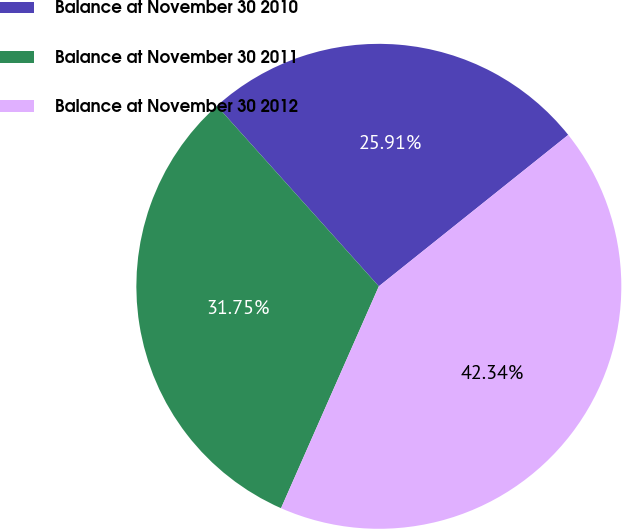<chart> <loc_0><loc_0><loc_500><loc_500><pie_chart><fcel>Balance at November 30 2010<fcel>Balance at November 30 2011<fcel>Balance at November 30 2012<nl><fcel>25.91%<fcel>31.75%<fcel>42.34%<nl></chart> 